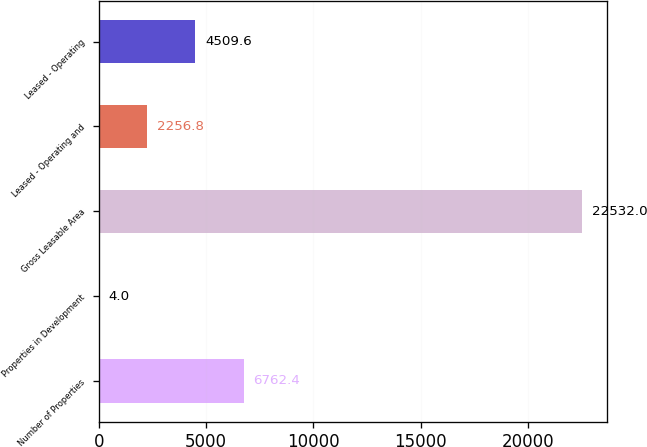Convert chart. <chart><loc_0><loc_0><loc_500><loc_500><bar_chart><fcel>Number of Properties<fcel>Properties in Development<fcel>Gross Leasable Area<fcel>Leased - Operating and<fcel>Leased - Operating<nl><fcel>6762.4<fcel>4<fcel>22532<fcel>2256.8<fcel>4509.6<nl></chart> 